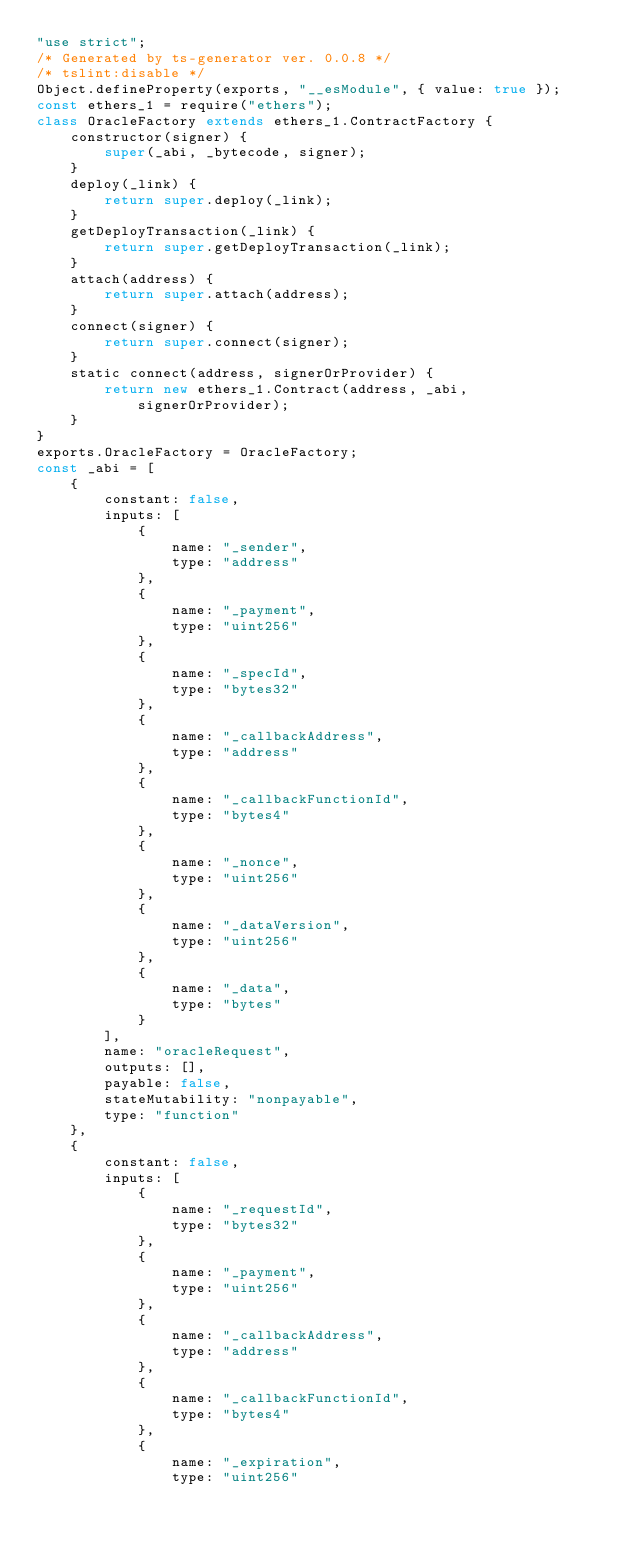<code> <loc_0><loc_0><loc_500><loc_500><_JavaScript_>"use strict";
/* Generated by ts-generator ver. 0.0.8 */
/* tslint:disable */
Object.defineProperty(exports, "__esModule", { value: true });
const ethers_1 = require("ethers");
class OracleFactory extends ethers_1.ContractFactory {
    constructor(signer) {
        super(_abi, _bytecode, signer);
    }
    deploy(_link) {
        return super.deploy(_link);
    }
    getDeployTransaction(_link) {
        return super.getDeployTransaction(_link);
    }
    attach(address) {
        return super.attach(address);
    }
    connect(signer) {
        return super.connect(signer);
    }
    static connect(address, signerOrProvider) {
        return new ethers_1.Contract(address, _abi, signerOrProvider);
    }
}
exports.OracleFactory = OracleFactory;
const _abi = [
    {
        constant: false,
        inputs: [
            {
                name: "_sender",
                type: "address"
            },
            {
                name: "_payment",
                type: "uint256"
            },
            {
                name: "_specId",
                type: "bytes32"
            },
            {
                name: "_callbackAddress",
                type: "address"
            },
            {
                name: "_callbackFunctionId",
                type: "bytes4"
            },
            {
                name: "_nonce",
                type: "uint256"
            },
            {
                name: "_dataVersion",
                type: "uint256"
            },
            {
                name: "_data",
                type: "bytes"
            }
        ],
        name: "oracleRequest",
        outputs: [],
        payable: false,
        stateMutability: "nonpayable",
        type: "function"
    },
    {
        constant: false,
        inputs: [
            {
                name: "_requestId",
                type: "bytes32"
            },
            {
                name: "_payment",
                type: "uint256"
            },
            {
                name: "_callbackAddress",
                type: "address"
            },
            {
                name: "_callbackFunctionId",
                type: "bytes4"
            },
            {
                name: "_expiration",
                type: "uint256"</code> 